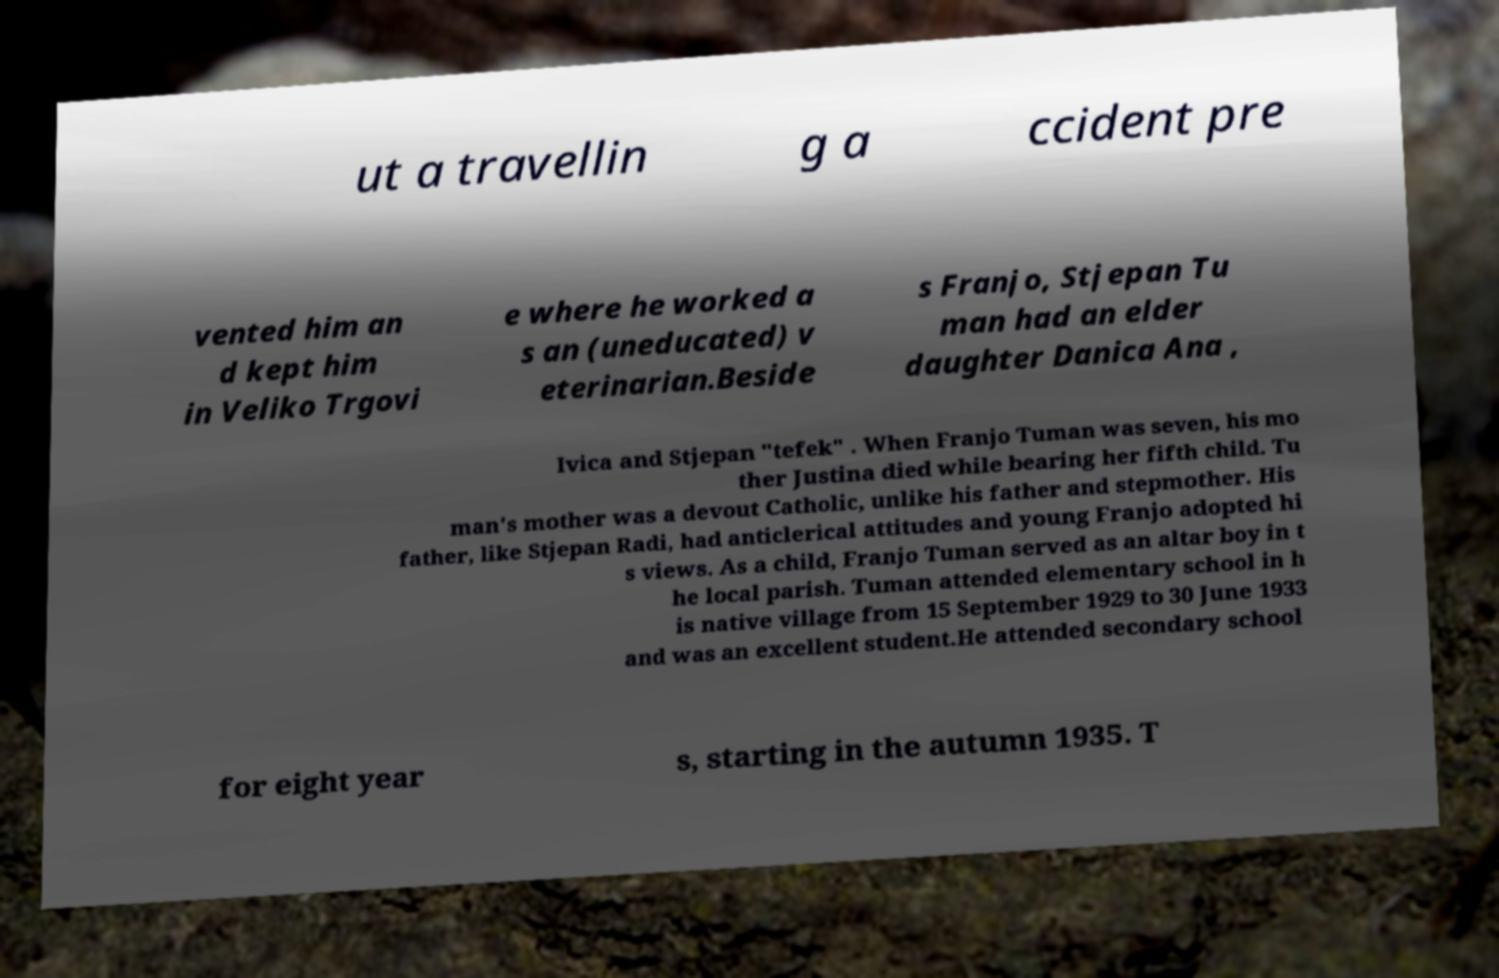Can you accurately transcribe the text from the provided image for me? ut a travellin g a ccident pre vented him an d kept him in Veliko Trgovi e where he worked a s an (uneducated) v eterinarian.Beside s Franjo, Stjepan Tu man had an elder daughter Danica Ana , Ivica and Stjepan "tefek" . When Franjo Tuman was seven, his mo ther Justina died while bearing her fifth child. Tu man's mother was a devout Catholic, unlike his father and stepmother. His father, like Stjepan Radi, had anticlerical attitudes and young Franjo adopted hi s views. As a child, Franjo Tuman served as an altar boy in t he local parish. Tuman attended elementary school in h is native village from 15 September 1929 to 30 June 1933 and was an excellent student.He attended secondary school for eight year s, starting in the autumn 1935. T 